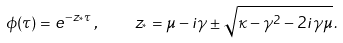<formula> <loc_0><loc_0><loc_500><loc_500>\phi ( \tau ) = e ^ { - z _ { ^ { * } } \tau } \, , \quad z _ { ^ { * } } = \mu - i \gamma \pm \sqrt { \kappa - \gamma ^ { 2 } - 2 i \gamma \mu } \, .</formula> 